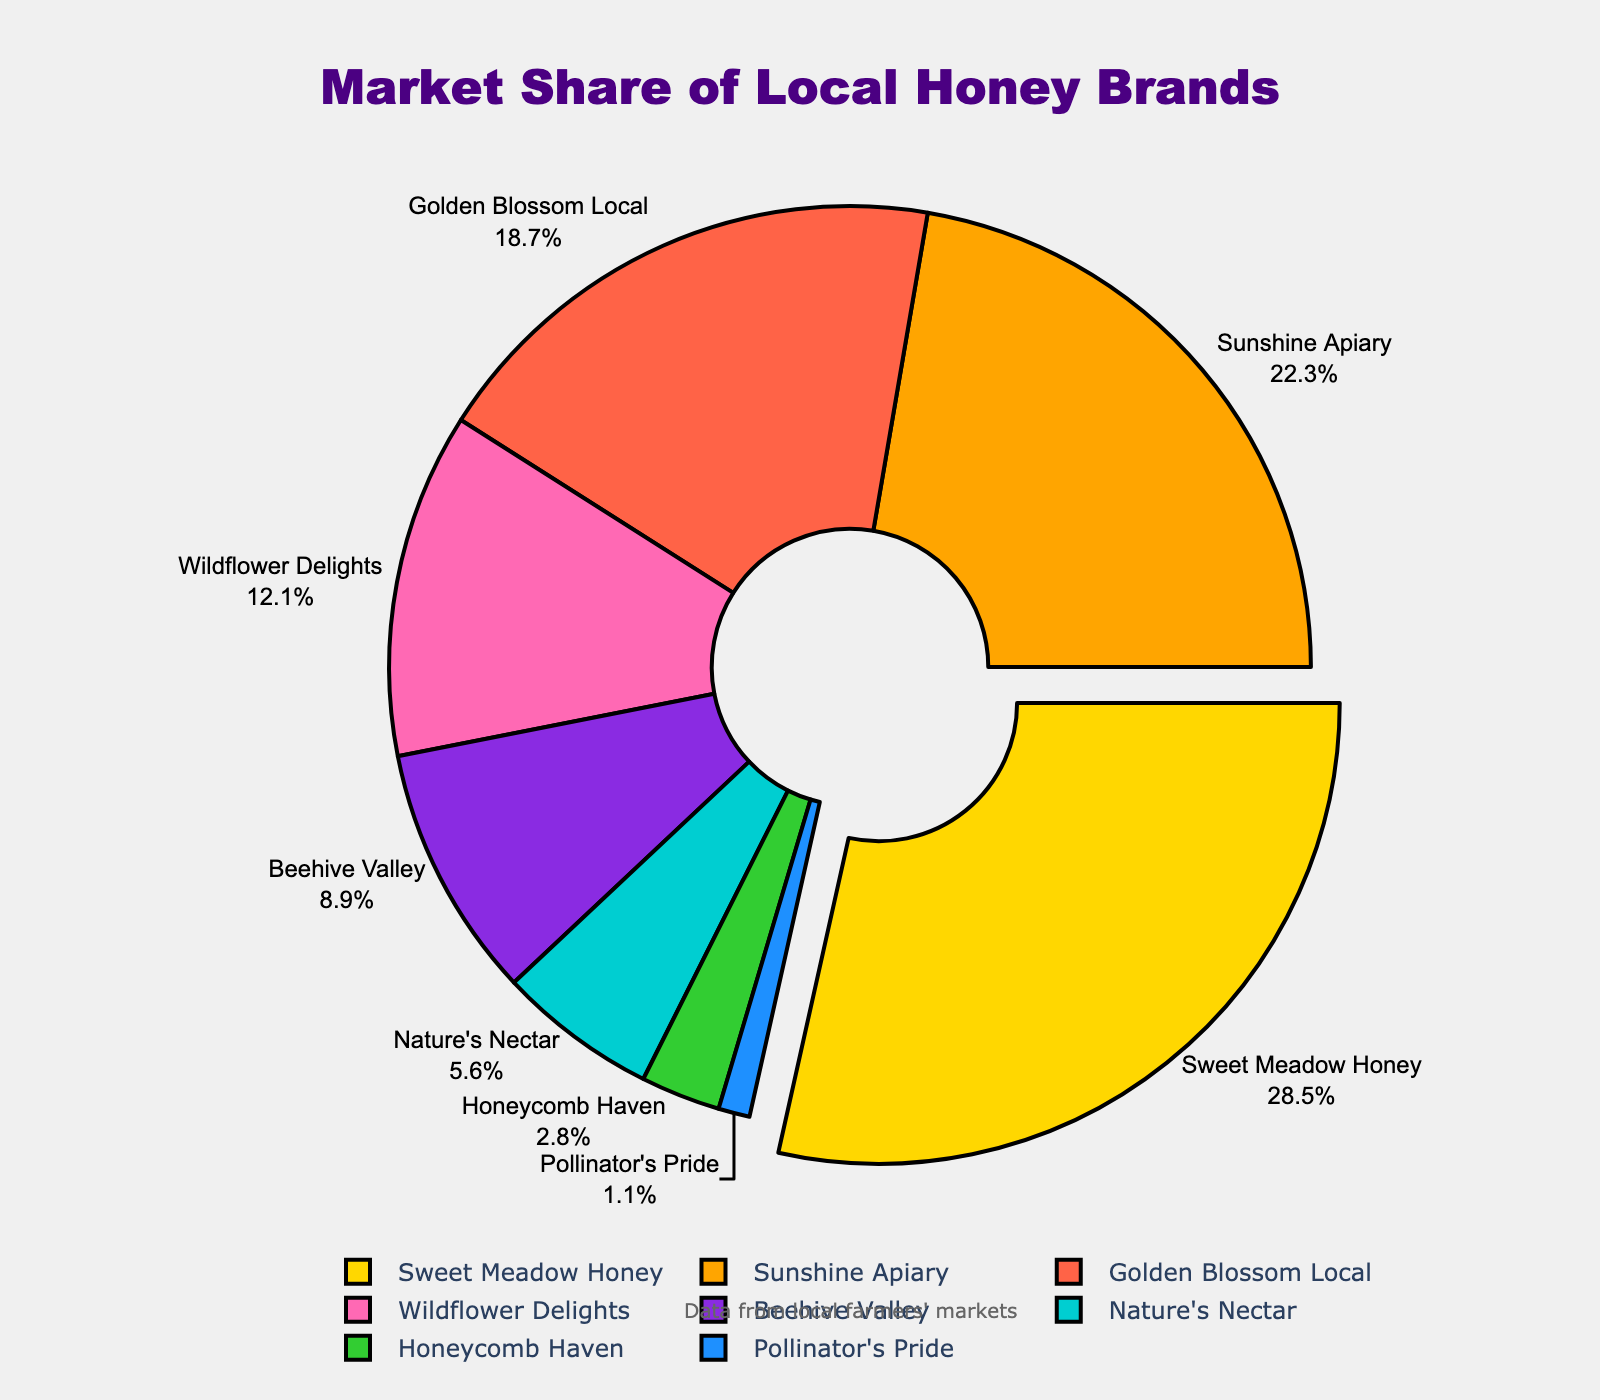Which honey brand has the highest market share? Sweet Meadow Honey occupies the largest portion of the pie chart
Answer: Sweet Meadow Honey What's the total market share of Golden Blossom Local and Beehive Valley combined? The market share of Golden Blossom Local is 18.7, and Beehive Valley is 8.9, so their combined market share is 18.7 + 8.9 = 27.6
Answer: 27.6 How does the market share of Sunshine Apiary compare to that of Wildflower Delights? Sunshine Apiary's market share is 22.3, which is higher than Wildflower Delights' 12.1
Answer: Sunshine Apiary has a higher market share Calculate the difference in market share between the brand with the largest share and the brand with the smallest share. Sweet Meadow Honey has the largest share at 28.5, and Pollinator's Pride has the smallest share at 1.1. The difference is 28.5 - 1.1 = 27.4
Answer: 27.4 What percent of the market is held by brands with a share less than 10%? Brands with less than 10% are Beehive Valley (8.9), Nature's Nectar (5.6), Honeycomb Haven (2.8), and Pollinator's Pride (1.1). Their total is 8.9 + 5.6 + 2.8 + 1.1 = 18.4
Answer: 18.4 Which brand's slice is blue in color? The text font and slice colors mark Honeycomb Haven with the blue color
Answer: Honeycomb Haven What is the central angle corresponding to Nature's Nectar's market share? Nature’s Nectar has a market share of 5.6%. The central angle for a sector is given by (percent/100) * 360. So, (5.6/100) * 360 = 20.16 degrees
Answer: 20.16 degrees If Sweet Meadow Honey's market share increases by 5%, what will be its new market share? Sweet Meadow Honey’s current market share is 28.5%. If it increases by 5%, the new market share will be 28.5 + 5 = 33.5%
Answer: 33.5% Which honey brands together hold more than 50% of the market share? Sweet Meadow Honey (28.5) and Sunshine Apiary (22.3) together have 28.5 + 22.3 = 50.8, which is more than 50%
Answer: Sweet Meadow Honey and Sunshine Apiary 